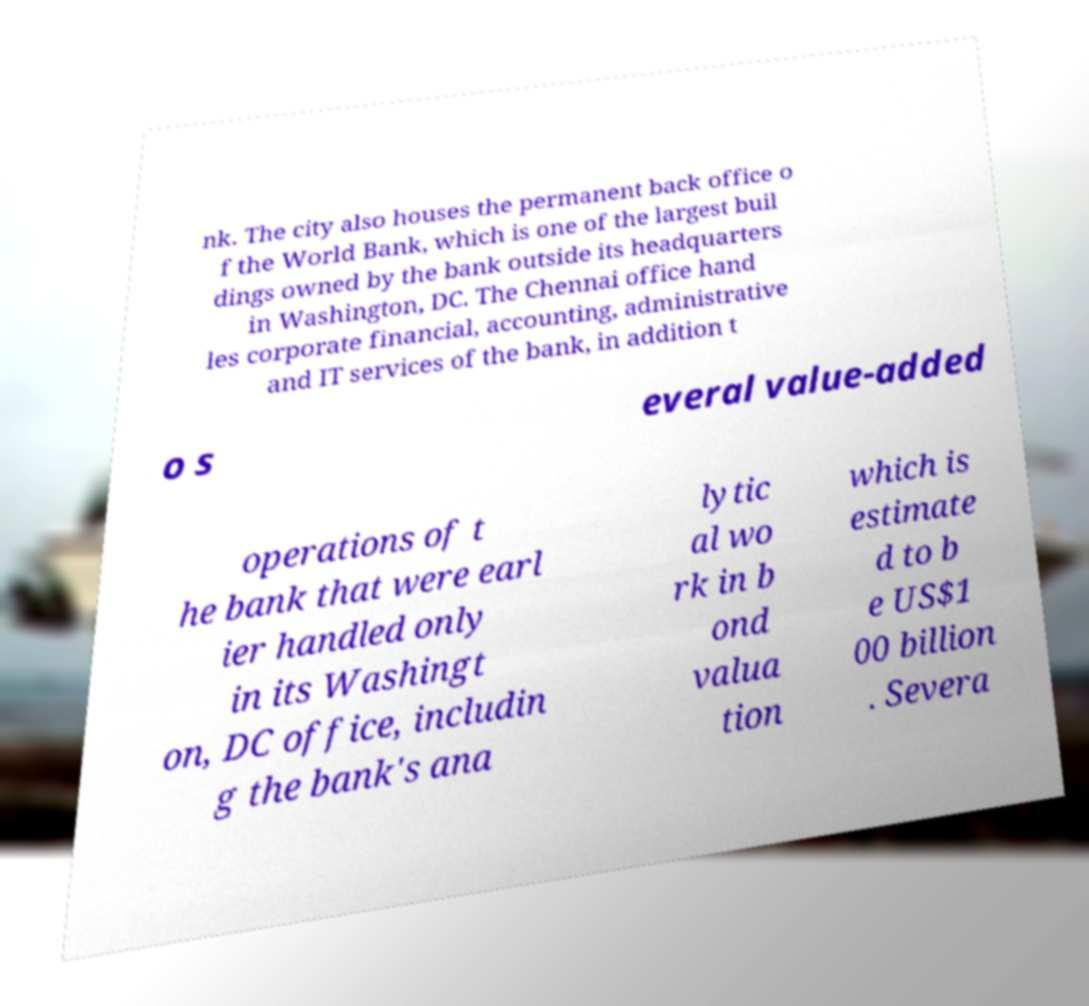There's text embedded in this image that I need extracted. Can you transcribe it verbatim? nk. The city also houses the permanent back office o f the World Bank, which is one of the largest buil dings owned by the bank outside its headquarters in Washington, DC. The Chennai office hand les corporate financial, accounting, administrative and IT services of the bank, in addition t o s everal value-added operations of t he bank that were earl ier handled only in its Washingt on, DC office, includin g the bank's ana lytic al wo rk in b ond valua tion which is estimate d to b e US$1 00 billion . Severa 